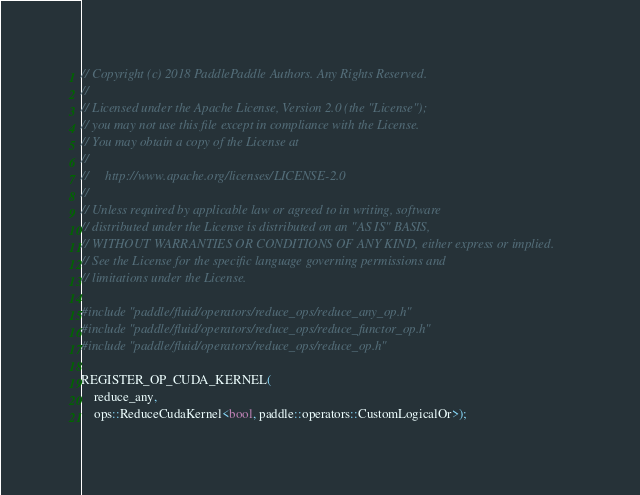<code> <loc_0><loc_0><loc_500><loc_500><_Cuda_>// Copyright (c) 2018 PaddlePaddle Authors. Any Rights Reserved.
//
// Licensed under the Apache License, Version 2.0 (the "License");
// you may not use this file except in compliance with the License.
// You may obtain a copy of the License at
//
//     http://www.apache.org/licenses/LICENSE-2.0
//
// Unless required by applicable law or agreed to in writing, software
// distributed under the License is distributed on an "AS IS" BASIS,
// WITHOUT WARRANTIES OR CONDITIONS OF ANY KIND, either express or implied.
// See the License for the specific language governing permissions and
// limitations under the License.

#include "paddle/fluid/operators/reduce_ops/reduce_any_op.h"
#include "paddle/fluid/operators/reduce_ops/reduce_functor_op.h"
#include "paddle/fluid/operators/reduce_ops/reduce_op.h"

REGISTER_OP_CUDA_KERNEL(
    reduce_any,
    ops::ReduceCudaKernel<bool, paddle::operators::CustomLogicalOr>);
</code> 